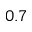Convert formula to latex. <formula><loc_0><loc_0><loc_500><loc_500>0 . 7</formula> 